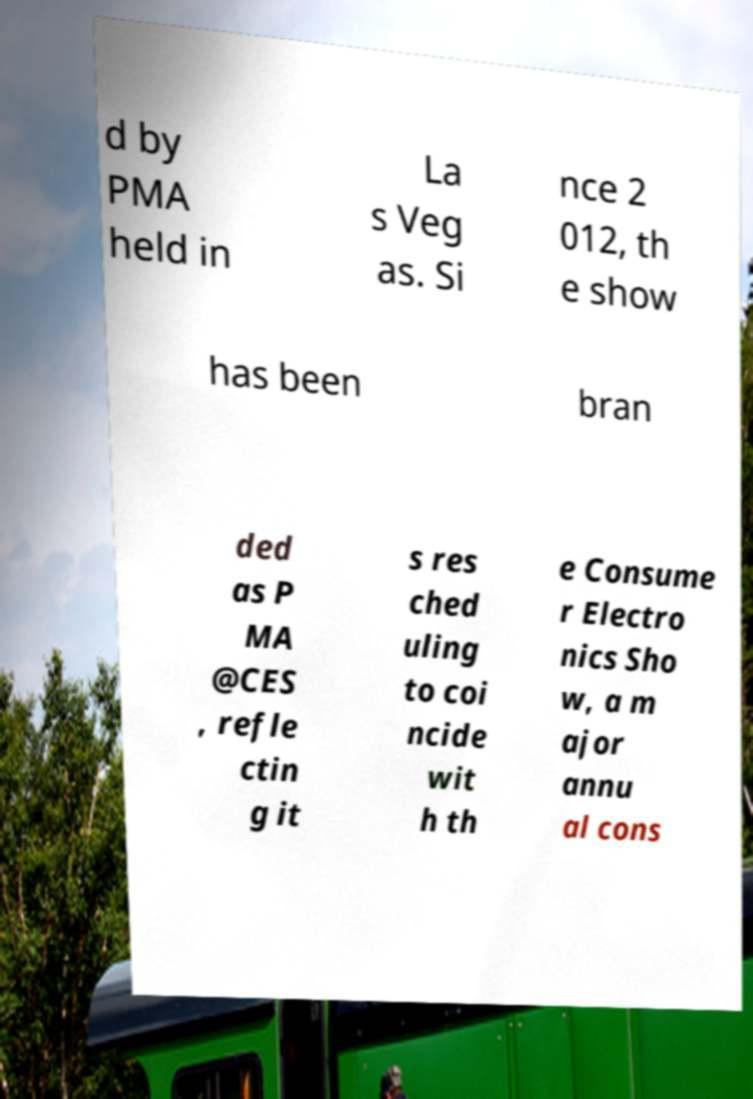Please identify and transcribe the text found in this image. d by PMA held in La s Veg as. Si nce 2 012, th e show has been bran ded as P MA @CES , refle ctin g it s res ched uling to coi ncide wit h th e Consume r Electro nics Sho w, a m ajor annu al cons 